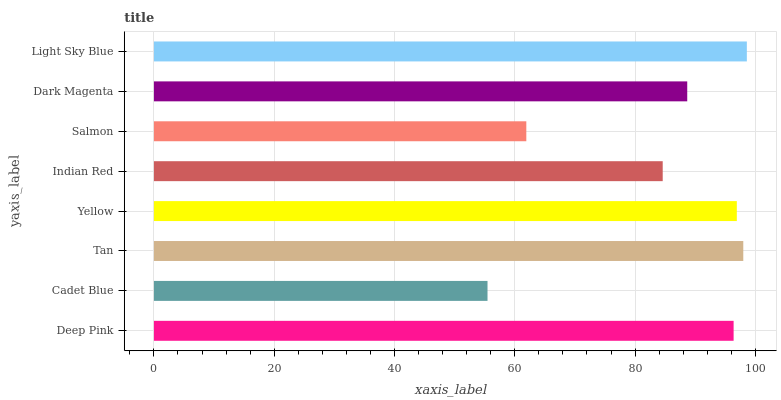Is Cadet Blue the minimum?
Answer yes or no. Yes. Is Light Sky Blue the maximum?
Answer yes or no. Yes. Is Tan the minimum?
Answer yes or no. No. Is Tan the maximum?
Answer yes or no. No. Is Tan greater than Cadet Blue?
Answer yes or no. Yes. Is Cadet Blue less than Tan?
Answer yes or no. Yes. Is Cadet Blue greater than Tan?
Answer yes or no. No. Is Tan less than Cadet Blue?
Answer yes or no. No. Is Deep Pink the high median?
Answer yes or no. Yes. Is Dark Magenta the low median?
Answer yes or no. Yes. Is Indian Red the high median?
Answer yes or no. No. Is Yellow the low median?
Answer yes or no. No. 